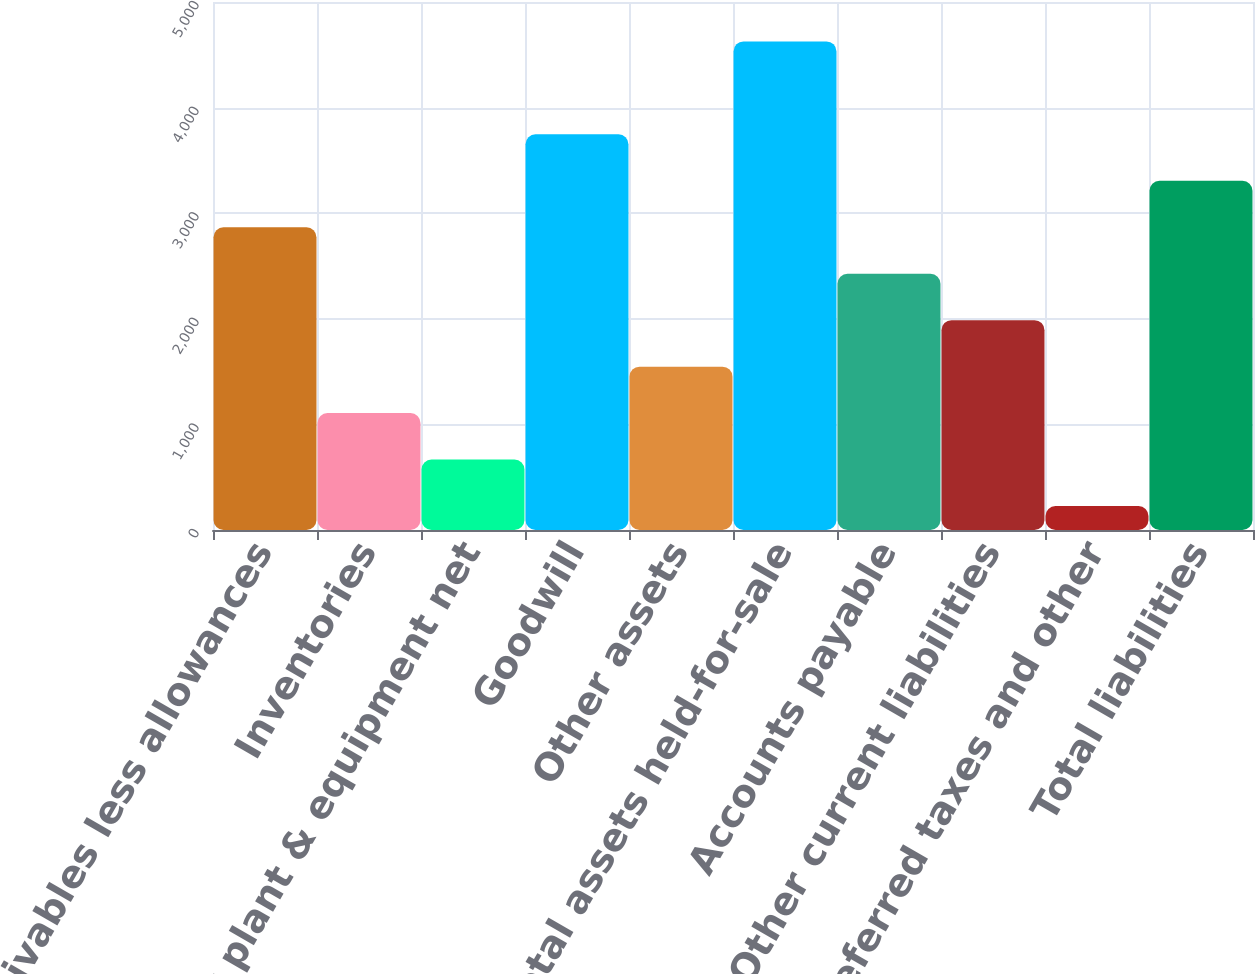Convert chart. <chart><loc_0><loc_0><loc_500><loc_500><bar_chart><fcel>Receivables less allowances<fcel>Inventories<fcel>Property plant & equipment net<fcel>Goodwill<fcel>Other assets<fcel>Total assets held-for-sale<fcel>Accounts payable<fcel>Other current liabilities<fcel>Deferred taxes and other<fcel>Total liabilities<nl><fcel>2867<fcel>1107<fcel>667<fcel>3747<fcel>1547<fcel>4627<fcel>2427<fcel>1987<fcel>227<fcel>3307<nl></chart> 